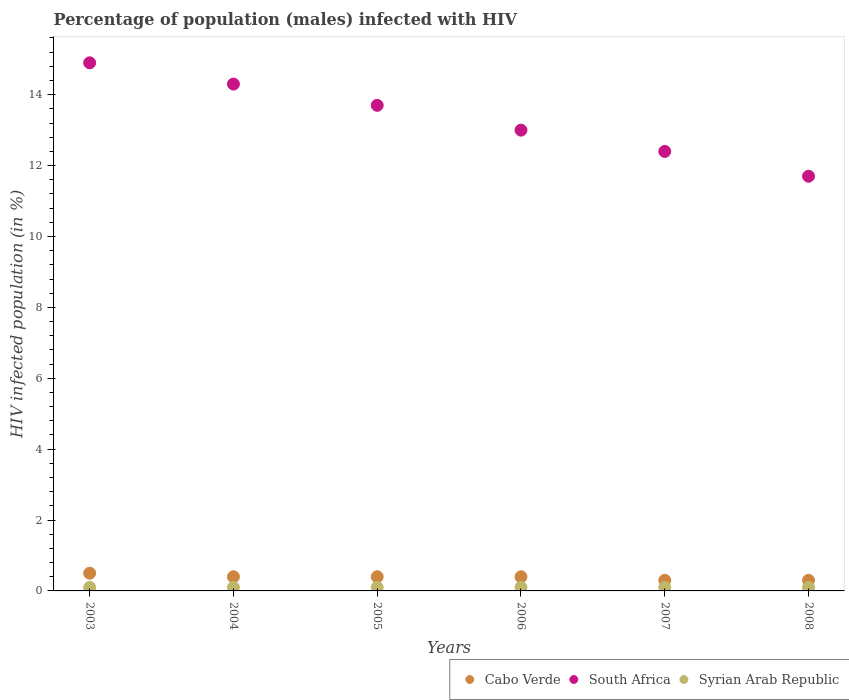How many different coloured dotlines are there?
Offer a very short reply. 3. What is the percentage of HIV infected male population in Cabo Verde in 2006?
Ensure brevity in your answer.  0.4. What is the difference between the percentage of HIV infected male population in South Africa in 2003 and that in 2008?
Offer a very short reply. 3.2. What is the difference between the percentage of HIV infected male population in Cabo Verde in 2004 and the percentage of HIV infected male population in Syrian Arab Republic in 2008?
Your answer should be compact. 0.3. What is the average percentage of HIV infected male population in Cabo Verde per year?
Offer a very short reply. 0.38. In the year 2004, what is the difference between the percentage of HIV infected male population in Cabo Verde and percentage of HIV infected male population in Syrian Arab Republic?
Keep it short and to the point. 0.3. What is the ratio of the percentage of HIV infected male population in Syrian Arab Republic in 2004 to that in 2007?
Make the answer very short. 1. Is the percentage of HIV infected male population in Cabo Verde in 2003 less than that in 2006?
Keep it short and to the point. No. What is the difference between the highest and the lowest percentage of HIV infected male population in South Africa?
Offer a very short reply. 3.2. In how many years, is the percentage of HIV infected male population in Syrian Arab Republic greater than the average percentage of HIV infected male population in Syrian Arab Republic taken over all years?
Your response must be concise. 6. Is the sum of the percentage of HIV infected male population in Syrian Arab Republic in 2006 and 2008 greater than the maximum percentage of HIV infected male population in Cabo Verde across all years?
Make the answer very short. No. Is it the case that in every year, the sum of the percentage of HIV infected male population in South Africa and percentage of HIV infected male population in Syrian Arab Republic  is greater than the percentage of HIV infected male population in Cabo Verde?
Give a very brief answer. Yes. Does the percentage of HIV infected male population in South Africa monotonically increase over the years?
Give a very brief answer. No. How many dotlines are there?
Offer a very short reply. 3. How many years are there in the graph?
Your answer should be very brief. 6. Are the values on the major ticks of Y-axis written in scientific E-notation?
Offer a very short reply. No. Where does the legend appear in the graph?
Your answer should be very brief. Bottom right. How many legend labels are there?
Ensure brevity in your answer.  3. How are the legend labels stacked?
Keep it short and to the point. Horizontal. What is the title of the graph?
Make the answer very short. Percentage of population (males) infected with HIV. Does "Isle of Man" appear as one of the legend labels in the graph?
Your response must be concise. No. What is the label or title of the X-axis?
Your answer should be compact. Years. What is the label or title of the Y-axis?
Your answer should be very brief. HIV infected population (in %). What is the HIV infected population (in %) in Cabo Verde in 2003?
Your answer should be compact. 0.5. What is the HIV infected population (in %) in South Africa in 2003?
Provide a succinct answer. 14.9. What is the HIV infected population (in %) of Syrian Arab Republic in 2004?
Give a very brief answer. 0.1. What is the HIV infected population (in %) in Cabo Verde in 2005?
Keep it short and to the point. 0.4. What is the HIV infected population (in %) of South Africa in 2005?
Your response must be concise. 13.7. What is the HIV infected population (in %) in Syrian Arab Republic in 2005?
Your response must be concise. 0.1. What is the HIV infected population (in %) in Syrian Arab Republic in 2006?
Give a very brief answer. 0.1. What is the HIV infected population (in %) in Cabo Verde in 2007?
Keep it short and to the point. 0.3. What is the HIV infected population (in %) of South Africa in 2007?
Your response must be concise. 12.4. What is the HIV infected population (in %) in Syrian Arab Republic in 2007?
Your response must be concise. 0.1. What is the HIV infected population (in %) of South Africa in 2008?
Offer a terse response. 11.7. What is the HIV infected population (in %) in Syrian Arab Republic in 2008?
Make the answer very short. 0.1. Across all years, what is the maximum HIV infected population (in %) of Cabo Verde?
Give a very brief answer. 0.5. Across all years, what is the maximum HIV infected population (in %) of South Africa?
Provide a short and direct response. 14.9. Across all years, what is the minimum HIV infected population (in %) in South Africa?
Your response must be concise. 11.7. Across all years, what is the minimum HIV infected population (in %) of Syrian Arab Republic?
Ensure brevity in your answer.  0.1. What is the difference between the HIV infected population (in %) in South Africa in 2003 and that in 2004?
Offer a very short reply. 0.6. What is the difference between the HIV infected population (in %) in Syrian Arab Republic in 2003 and that in 2004?
Your response must be concise. 0. What is the difference between the HIV infected population (in %) in South Africa in 2003 and that in 2005?
Make the answer very short. 1.2. What is the difference between the HIV infected population (in %) in Cabo Verde in 2003 and that in 2006?
Provide a short and direct response. 0.1. What is the difference between the HIV infected population (in %) in South Africa in 2003 and that in 2006?
Offer a terse response. 1.9. What is the difference between the HIV infected population (in %) in South Africa in 2003 and that in 2007?
Your answer should be compact. 2.5. What is the difference between the HIV infected population (in %) of Syrian Arab Republic in 2003 and that in 2007?
Offer a very short reply. 0. What is the difference between the HIV infected population (in %) of Cabo Verde in 2003 and that in 2008?
Provide a succinct answer. 0.2. What is the difference between the HIV infected population (in %) in Syrian Arab Republic in 2003 and that in 2008?
Ensure brevity in your answer.  0. What is the difference between the HIV infected population (in %) in South Africa in 2004 and that in 2005?
Ensure brevity in your answer.  0.6. What is the difference between the HIV infected population (in %) of Syrian Arab Republic in 2004 and that in 2005?
Provide a short and direct response. 0. What is the difference between the HIV infected population (in %) of South Africa in 2004 and that in 2007?
Keep it short and to the point. 1.9. What is the difference between the HIV infected population (in %) in South Africa in 2004 and that in 2008?
Provide a short and direct response. 2.6. What is the difference between the HIV infected population (in %) of Syrian Arab Republic in 2004 and that in 2008?
Give a very brief answer. 0. What is the difference between the HIV infected population (in %) of Cabo Verde in 2005 and that in 2006?
Make the answer very short. 0. What is the difference between the HIV infected population (in %) of South Africa in 2005 and that in 2006?
Ensure brevity in your answer.  0.7. What is the difference between the HIV infected population (in %) of Syrian Arab Republic in 2005 and that in 2006?
Ensure brevity in your answer.  0. What is the difference between the HIV infected population (in %) of Cabo Verde in 2005 and that in 2008?
Keep it short and to the point. 0.1. What is the difference between the HIV infected population (in %) of Syrian Arab Republic in 2005 and that in 2008?
Make the answer very short. 0. What is the difference between the HIV infected population (in %) in Syrian Arab Republic in 2006 and that in 2007?
Ensure brevity in your answer.  0. What is the difference between the HIV infected population (in %) of Cabo Verde in 2006 and that in 2008?
Offer a very short reply. 0.1. What is the difference between the HIV infected population (in %) in Cabo Verde in 2007 and that in 2008?
Your answer should be compact. 0. What is the difference between the HIV infected population (in %) in Cabo Verde in 2003 and the HIV infected population (in %) in Syrian Arab Republic in 2005?
Your response must be concise. 0.4. What is the difference between the HIV infected population (in %) of South Africa in 2003 and the HIV infected population (in %) of Syrian Arab Republic in 2005?
Offer a very short reply. 14.8. What is the difference between the HIV infected population (in %) in Cabo Verde in 2003 and the HIV infected population (in %) in Syrian Arab Republic in 2006?
Offer a terse response. 0.4. What is the difference between the HIV infected population (in %) in South Africa in 2003 and the HIV infected population (in %) in Syrian Arab Republic in 2006?
Make the answer very short. 14.8. What is the difference between the HIV infected population (in %) of Cabo Verde in 2003 and the HIV infected population (in %) of South Africa in 2007?
Provide a succinct answer. -11.9. What is the difference between the HIV infected population (in %) of South Africa in 2003 and the HIV infected population (in %) of Syrian Arab Republic in 2007?
Offer a terse response. 14.8. What is the difference between the HIV infected population (in %) of Cabo Verde in 2003 and the HIV infected population (in %) of South Africa in 2008?
Offer a very short reply. -11.2. What is the difference between the HIV infected population (in %) in Cabo Verde in 2003 and the HIV infected population (in %) in Syrian Arab Republic in 2008?
Offer a very short reply. 0.4. What is the difference between the HIV infected population (in %) in Cabo Verde in 2004 and the HIV infected population (in %) in South Africa in 2005?
Your response must be concise. -13.3. What is the difference between the HIV infected population (in %) in Cabo Verde in 2004 and the HIV infected population (in %) in Syrian Arab Republic in 2006?
Provide a short and direct response. 0.3. What is the difference between the HIV infected population (in %) of Cabo Verde in 2004 and the HIV infected population (in %) of Syrian Arab Republic in 2007?
Your response must be concise. 0.3. What is the difference between the HIV infected population (in %) in South Africa in 2004 and the HIV infected population (in %) in Syrian Arab Republic in 2007?
Give a very brief answer. 14.2. What is the difference between the HIV infected population (in %) of Cabo Verde in 2004 and the HIV infected population (in %) of South Africa in 2008?
Offer a terse response. -11.3. What is the difference between the HIV infected population (in %) of South Africa in 2004 and the HIV infected population (in %) of Syrian Arab Republic in 2008?
Give a very brief answer. 14.2. What is the difference between the HIV infected population (in %) of Cabo Verde in 2005 and the HIV infected population (in %) of Syrian Arab Republic in 2006?
Your answer should be compact. 0.3. What is the difference between the HIV infected population (in %) of Cabo Verde in 2005 and the HIV infected population (in %) of Syrian Arab Republic in 2007?
Offer a very short reply. 0.3. What is the difference between the HIV infected population (in %) of Cabo Verde in 2005 and the HIV infected population (in %) of South Africa in 2008?
Your answer should be very brief. -11.3. What is the difference between the HIV infected population (in %) of South Africa in 2005 and the HIV infected population (in %) of Syrian Arab Republic in 2008?
Ensure brevity in your answer.  13.6. What is the difference between the HIV infected population (in %) of Cabo Verde in 2006 and the HIV infected population (in %) of Syrian Arab Republic in 2008?
Your answer should be compact. 0.3. What is the difference between the HIV infected population (in %) in Cabo Verde in 2007 and the HIV infected population (in %) in South Africa in 2008?
Make the answer very short. -11.4. What is the difference between the HIV infected population (in %) of Cabo Verde in 2007 and the HIV infected population (in %) of Syrian Arab Republic in 2008?
Give a very brief answer. 0.2. What is the average HIV infected population (in %) in Cabo Verde per year?
Provide a short and direct response. 0.38. What is the average HIV infected population (in %) in South Africa per year?
Keep it short and to the point. 13.33. What is the average HIV infected population (in %) of Syrian Arab Republic per year?
Offer a terse response. 0.1. In the year 2003, what is the difference between the HIV infected population (in %) of Cabo Verde and HIV infected population (in %) of South Africa?
Offer a very short reply. -14.4. In the year 2004, what is the difference between the HIV infected population (in %) of Cabo Verde and HIV infected population (in %) of Syrian Arab Republic?
Ensure brevity in your answer.  0.3. In the year 2004, what is the difference between the HIV infected population (in %) of South Africa and HIV infected population (in %) of Syrian Arab Republic?
Your answer should be very brief. 14.2. In the year 2005, what is the difference between the HIV infected population (in %) in Cabo Verde and HIV infected population (in %) in Syrian Arab Republic?
Your answer should be very brief. 0.3. In the year 2006, what is the difference between the HIV infected population (in %) in Cabo Verde and HIV infected population (in %) in Syrian Arab Republic?
Give a very brief answer. 0.3. In the year 2007, what is the difference between the HIV infected population (in %) in South Africa and HIV infected population (in %) in Syrian Arab Republic?
Provide a succinct answer. 12.3. What is the ratio of the HIV infected population (in %) in Cabo Verde in 2003 to that in 2004?
Ensure brevity in your answer.  1.25. What is the ratio of the HIV infected population (in %) of South Africa in 2003 to that in 2004?
Keep it short and to the point. 1.04. What is the ratio of the HIV infected population (in %) in South Africa in 2003 to that in 2005?
Provide a short and direct response. 1.09. What is the ratio of the HIV infected population (in %) of South Africa in 2003 to that in 2006?
Give a very brief answer. 1.15. What is the ratio of the HIV infected population (in %) of Syrian Arab Republic in 2003 to that in 2006?
Keep it short and to the point. 1. What is the ratio of the HIV infected population (in %) of South Africa in 2003 to that in 2007?
Make the answer very short. 1.2. What is the ratio of the HIV infected population (in %) of Syrian Arab Republic in 2003 to that in 2007?
Give a very brief answer. 1. What is the ratio of the HIV infected population (in %) in South Africa in 2003 to that in 2008?
Make the answer very short. 1.27. What is the ratio of the HIV infected population (in %) of Syrian Arab Republic in 2003 to that in 2008?
Your answer should be compact. 1. What is the ratio of the HIV infected population (in %) of Cabo Verde in 2004 to that in 2005?
Give a very brief answer. 1. What is the ratio of the HIV infected population (in %) in South Africa in 2004 to that in 2005?
Ensure brevity in your answer.  1.04. What is the ratio of the HIV infected population (in %) of Syrian Arab Republic in 2004 to that in 2006?
Provide a short and direct response. 1. What is the ratio of the HIV infected population (in %) in South Africa in 2004 to that in 2007?
Make the answer very short. 1.15. What is the ratio of the HIV infected population (in %) of Cabo Verde in 2004 to that in 2008?
Make the answer very short. 1.33. What is the ratio of the HIV infected population (in %) of South Africa in 2004 to that in 2008?
Ensure brevity in your answer.  1.22. What is the ratio of the HIV infected population (in %) in Cabo Verde in 2005 to that in 2006?
Your answer should be compact. 1. What is the ratio of the HIV infected population (in %) in South Africa in 2005 to that in 2006?
Offer a very short reply. 1.05. What is the ratio of the HIV infected population (in %) of Syrian Arab Republic in 2005 to that in 2006?
Offer a very short reply. 1. What is the ratio of the HIV infected population (in %) in Cabo Verde in 2005 to that in 2007?
Your response must be concise. 1.33. What is the ratio of the HIV infected population (in %) of South Africa in 2005 to that in 2007?
Your answer should be compact. 1.1. What is the ratio of the HIV infected population (in %) of Syrian Arab Republic in 2005 to that in 2007?
Provide a short and direct response. 1. What is the ratio of the HIV infected population (in %) of South Africa in 2005 to that in 2008?
Your answer should be very brief. 1.17. What is the ratio of the HIV infected population (in %) in Cabo Verde in 2006 to that in 2007?
Provide a short and direct response. 1.33. What is the ratio of the HIV infected population (in %) of South Africa in 2006 to that in 2007?
Offer a terse response. 1.05. What is the ratio of the HIV infected population (in %) in Syrian Arab Republic in 2006 to that in 2007?
Give a very brief answer. 1. What is the ratio of the HIV infected population (in %) in South Africa in 2006 to that in 2008?
Ensure brevity in your answer.  1.11. What is the ratio of the HIV infected population (in %) of Syrian Arab Republic in 2006 to that in 2008?
Ensure brevity in your answer.  1. What is the ratio of the HIV infected population (in %) of South Africa in 2007 to that in 2008?
Offer a very short reply. 1.06. What is the ratio of the HIV infected population (in %) of Syrian Arab Republic in 2007 to that in 2008?
Your answer should be very brief. 1. What is the difference between the highest and the lowest HIV infected population (in %) in Cabo Verde?
Keep it short and to the point. 0.2. What is the difference between the highest and the lowest HIV infected population (in %) of South Africa?
Offer a terse response. 3.2. 